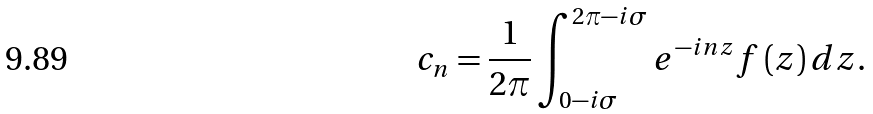Convert formula to latex. <formula><loc_0><loc_0><loc_500><loc_500>c _ { n } = \frac { 1 } { 2 \pi } \int _ { 0 - i \sigma } ^ { 2 \pi - i \sigma } e ^ { - i n z } f \left ( z \right ) d z .</formula> 